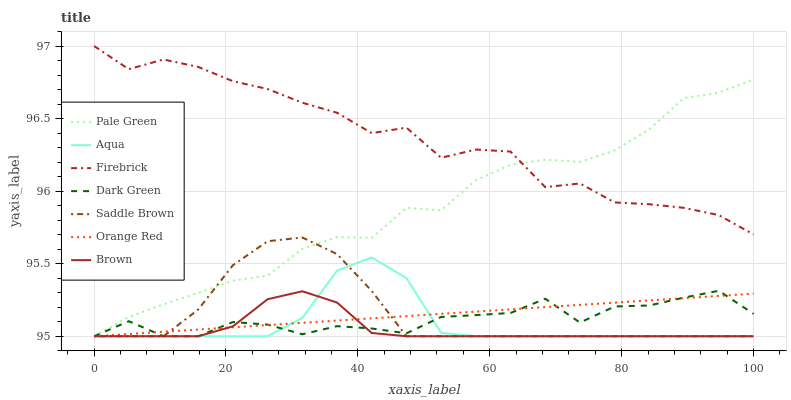Does Brown have the minimum area under the curve?
Answer yes or no. Yes. Does Firebrick have the maximum area under the curve?
Answer yes or no. Yes. Does Aqua have the minimum area under the curve?
Answer yes or no. No. Does Aqua have the maximum area under the curve?
Answer yes or no. No. Is Orange Red the smoothest?
Answer yes or no. Yes. Is Firebrick the roughest?
Answer yes or no. Yes. Is Aqua the smoothest?
Answer yes or no. No. Is Aqua the roughest?
Answer yes or no. No. Does Firebrick have the lowest value?
Answer yes or no. No. Does Firebrick have the highest value?
Answer yes or no. Yes. Does Aqua have the highest value?
Answer yes or no. No. Is Brown less than Firebrick?
Answer yes or no. Yes. Is Firebrick greater than Saddle Brown?
Answer yes or no. Yes. Does Saddle Brown intersect Orange Red?
Answer yes or no. Yes. Is Saddle Brown less than Orange Red?
Answer yes or no. No. Is Saddle Brown greater than Orange Red?
Answer yes or no. No. Does Brown intersect Firebrick?
Answer yes or no. No. 